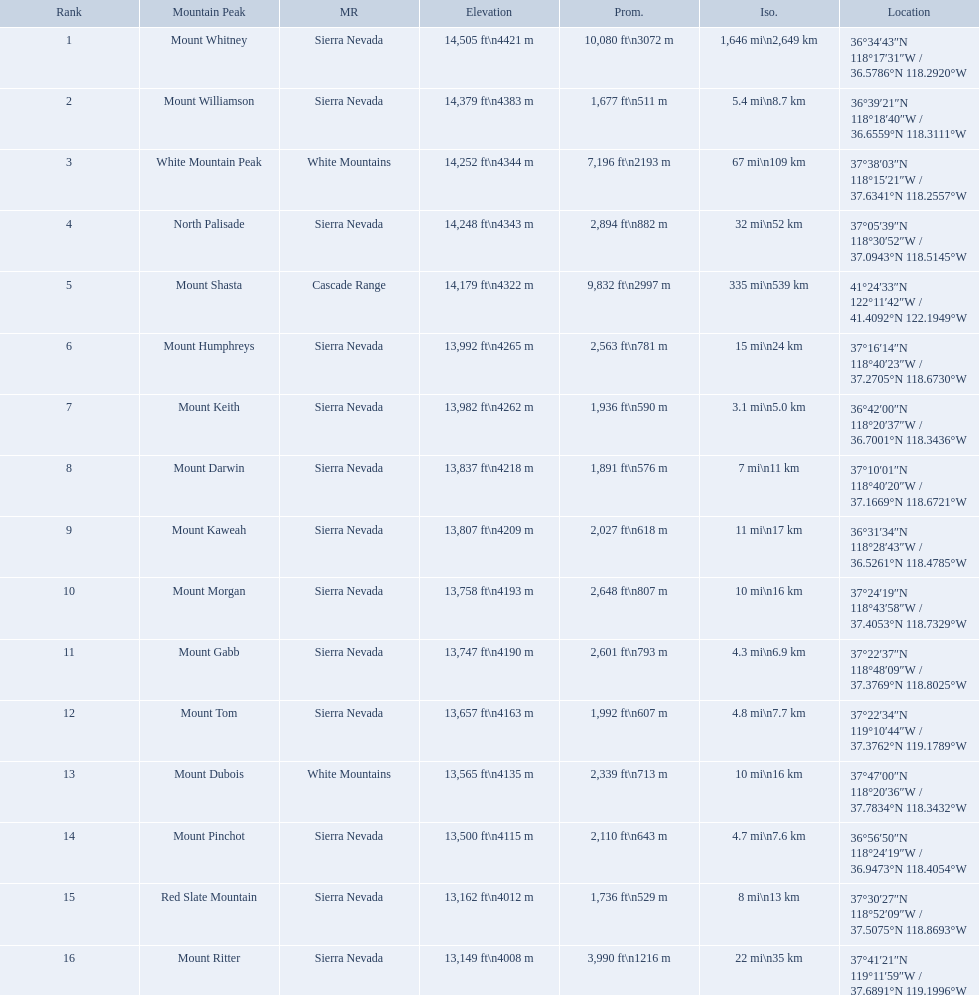What are all of the mountain peaks? Mount Whitney, Mount Williamson, White Mountain Peak, North Palisade, Mount Shasta, Mount Humphreys, Mount Keith, Mount Darwin, Mount Kaweah, Mount Morgan, Mount Gabb, Mount Tom, Mount Dubois, Mount Pinchot, Red Slate Mountain, Mount Ritter. In what ranges are they? Sierra Nevada, Sierra Nevada, White Mountains, Sierra Nevada, Cascade Range, Sierra Nevada, Sierra Nevada, Sierra Nevada, Sierra Nevada, Sierra Nevada, Sierra Nevada, Sierra Nevada, White Mountains, Sierra Nevada, Sierra Nevada, Sierra Nevada. Which peak is in the cascade range? Mount Shasta. Which mountain peaks have a prominence over 9,000 ft? Mount Whitney, Mount Shasta. Of those, which one has the the highest prominence? Mount Whitney. What are the heights of the californian mountain peaks? 14,505 ft\n4421 m, 14,379 ft\n4383 m, 14,252 ft\n4344 m, 14,248 ft\n4343 m, 14,179 ft\n4322 m, 13,992 ft\n4265 m, 13,982 ft\n4262 m, 13,837 ft\n4218 m, 13,807 ft\n4209 m, 13,758 ft\n4193 m, 13,747 ft\n4190 m, 13,657 ft\n4163 m, 13,565 ft\n4135 m, 13,500 ft\n4115 m, 13,162 ft\n4012 m, 13,149 ft\n4008 m. What elevation is 13,149 ft or less? 13,149 ft\n4008 m. What mountain peak is at this elevation? Mount Ritter. Would you mind parsing the complete table? {'header': ['Rank', 'Mountain Peak', 'MR', 'Elevation', 'Prom.', 'Iso.', 'Location'], 'rows': [['1', 'Mount Whitney', 'Sierra Nevada', '14,505\xa0ft\\n4421\xa0m', '10,080\xa0ft\\n3072\xa0m', '1,646\xa0mi\\n2,649\xa0km', '36°34′43″N 118°17′31″W\ufeff / \ufeff36.5786°N 118.2920°W'], ['2', 'Mount Williamson', 'Sierra Nevada', '14,379\xa0ft\\n4383\xa0m', '1,677\xa0ft\\n511\xa0m', '5.4\xa0mi\\n8.7\xa0km', '36°39′21″N 118°18′40″W\ufeff / \ufeff36.6559°N 118.3111°W'], ['3', 'White Mountain Peak', 'White Mountains', '14,252\xa0ft\\n4344\xa0m', '7,196\xa0ft\\n2193\xa0m', '67\xa0mi\\n109\xa0km', '37°38′03″N 118°15′21″W\ufeff / \ufeff37.6341°N 118.2557°W'], ['4', 'North Palisade', 'Sierra Nevada', '14,248\xa0ft\\n4343\xa0m', '2,894\xa0ft\\n882\xa0m', '32\xa0mi\\n52\xa0km', '37°05′39″N 118°30′52″W\ufeff / \ufeff37.0943°N 118.5145°W'], ['5', 'Mount Shasta', 'Cascade Range', '14,179\xa0ft\\n4322\xa0m', '9,832\xa0ft\\n2997\xa0m', '335\xa0mi\\n539\xa0km', '41°24′33″N 122°11′42″W\ufeff / \ufeff41.4092°N 122.1949°W'], ['6', 'Mount Humphreys', 'Sierra Nevada', '13,992\xa0ft\\n4265\xa0m', '2,563\xa0ft\\n781\xa0m', '15\xa0mi\\n24\xa0km', '37°16′14″N 118°40′23″W\ufeff / \ufeff37.2705°N 118.6730°W'], ['7', 'Mount Keith', 'Sierra Nevada', '13,982\xa0ft\\n4262\xa0m', '1,936\xa0ft\\n590\xa0m', '3.1\xa0mi\\n5.0\xa0km', '36°42′00″N 118°20′37″W\ufeff / \ufeff36.7001°N 118.3436°W'], ['8', 'Mount Darwin', 'Sierra Nevada', '13,837\xa0ft\\n4218\xa0m', '1,891\xa0ft\\n576\xa0m', '7\xa0mi\\n11\xa0km', '37°10′01″N 118°40′20″W\ufeff / \ufeff37.1669°N 118.6721°W'], ['9', 'Mount Kaweah', 'Sierra Nevada', '13,807\xa0ft\\n4209\xa0m', '2,027\xa0ft\\n618\xa0m', '11\xa0mi\\n17\xa0km', '36°31′34″N 118°28′43″W\ufeff / \ufeff36.5261°N 118.4785°W'], ['10', 'Mount Morgan', 'Sierra Nevada', '13,758\xa0ft\\n4193\xa0m', '2,648\xa0ft\\n807\xa0m', '10\xa0mi\\n16\xa0km', '37°24′19″N 118°43′58″W\ufeff / \ufeff37.4053°N 118.7329°W'], ['11', 'Mount Gabb', 'Sierra Nevada', '13,747\xa0ft\\n4190\xa0m', '2,601\xa0ft\\n793\xa0m', '4.3\xa0mi\\n6.9\xa0km', '37°22′37″N 118°48′09″W\ufeff / \ufeff37.3769°N 118.8025°W'], ['12', 'Mount Tom', 'Sierra Nevada', '13,657\xa0ft\\n4163\xa0m', '1,992\xa0ft\\n607\xa0m', '4.8\xa0mi\\n7.7\xa0km', '37°22′34″N 119°10′44″W\ufeff / \ufeff37.3762°N 119.1789°W'], ['13', 'Mount Dubois', 'White Mountains', '13,565\xa0ft\\n4135\xa0m', '2,339\xa0ft\\n713\xa0m', '10\xa0mi\\n16\xa0km', '37°47′00″N 118°20′36″W\ufeff / \ufeff37.7834°N 118.3432°W'], ['14', 'Mount Pinchot', 'Sierra Nevada', '13,500\xa0ft\\n4115\xa0m', '2,110\xa0ft\\n643\xa0m', '4.7\xa0mi\\n7.6\xa0km', '36°56′50″N 118°24′19″W\ufeff / \ufeff36.9473°N 118.4054°W'], ['15', 'Red Slate Mountain', 'Sierra Nevada', '13,162\xa0ft\\n4012\xa0m', '1,736\xa0ft\\n529\xa0m', '8\xa0mi\\n13\xa0km', '37°30′27″N 118°52′09″W\ufeff / \ufeff37.5075°N 118.8693°W'], ['16', 'Mount Ritter', 'Sierra Nevada', '13,149\xa0ft\\n4008\xa0m', '3,990\xa0ft\\n1216\xa0m', '22\xa0mi\\n35\xa0km', '37°41′21″N 119°11′59″W\ufeff / \ufeff37.6891°N 119.1996°W']]} What are the listed elevations? 14,505 ft\n4421 m, 14,379 ft\n4383 m, 14,252 ft\n4344 m, 14,248 ft\n4343 m, 14,179 ft\n4322 m, 13,992 ft\n4265 m, 13,982 ft\n4262 m, 13,837 ft\n4218 m, 13,807 ft\n4209 m, 13,758 ft\n4193 m, 13,747 ft\n4190 m, 13,657 ft\n4163 m, 13,565 ft\n4135 m, 13,500 ft\n4115 m, 13,162 ft\n4012 m, 13,149 ft\n4008 m. Which of those is 13,149 ft or below? 13,149 ft\n4008 m. To what mountain peak does that value correspond? Mount Ritter. What are all of the peaks? Mount Whitney, Mount Williamson, White Mountain Peak, North Palisade, Mount Shasta, Mount Humphreys, Mount Keith, Mount Darwin, Mount Kaweah, Mount Morgan, Mount Gabb, Mount Tom, Mount Dubois, Mount Pinchot, Red Slate Mountain, Mount Ritter. Where are they located? Sierra Nevada, Sierra Nevada, White Mountains, Sierra Nevada, Cascade Range, Sierra Nevada, Sierra Nevada, Sierra Nevada, Sierra Nevada, Sierra Nevada, Sierra Nevada, Sierra Nevada, White Mountains, Sierra Nevada, Sierra Nevada, Sierra Nevada. How tall are they? 14,505 ft\n4421 m, 14,379 ft\n4383 m, 14,252 ft\n4344 m, 14,248 ft\n4343 m, 14,179 ft\n4322 m, 13,992 ft\n4265 m, 13,982 ft\n4262 m, 13,837 ft\n4218 m, 13,807 ft\n4209 m, 13,758 ft\n4193 m, 13,747 ft\n4190 m, 13,657 ft\n4163 m, 13,565 ft\n4135 m, 13,500 ft\n4115 m, 13,162 ft\n4012 m, 13,149 ft\n4008 m. What about just the peaks in the sierra nevadas? 14,505 ft\n4421 m, 14,379 ft\n4383 m, 14,248 ft\n4343 m, 13,992 ft\n4265 m, 13,982 ft\n4262 m, 13,837 ft\n4218 m, 13,807 ft\n4209 m, 13,758 ft\n4193 m, 13,747 ft\n4190 m, 13,657 ft\n4163 m, 13,500 ft\n4115 m, 13,162 ft\n4012 m, 13,149 ft\n4008 m. And of those, which is the tallest? Mount Whitney. Which are the highest mountain peaks in california? Mount Whitney, Mount Williamson, White Mountain Peak, North Palisade, Mount Shasta, Mount Humphreys, Mount Keith, Mount Darwin, Mount Kaweah, Mount Morgan, Mount Gabb, Mount Tom, Mount Dubois, Mount Pinchot, Red Slate Mountain, Mount Ritter. Of those, which are not in the sierra nevada range? White Mountain Peak, Mount Shasta, Mount Dubois. Of the mountains not in the sierra nevada range, which is the only mountain in the cascades? Mount Shasta. 